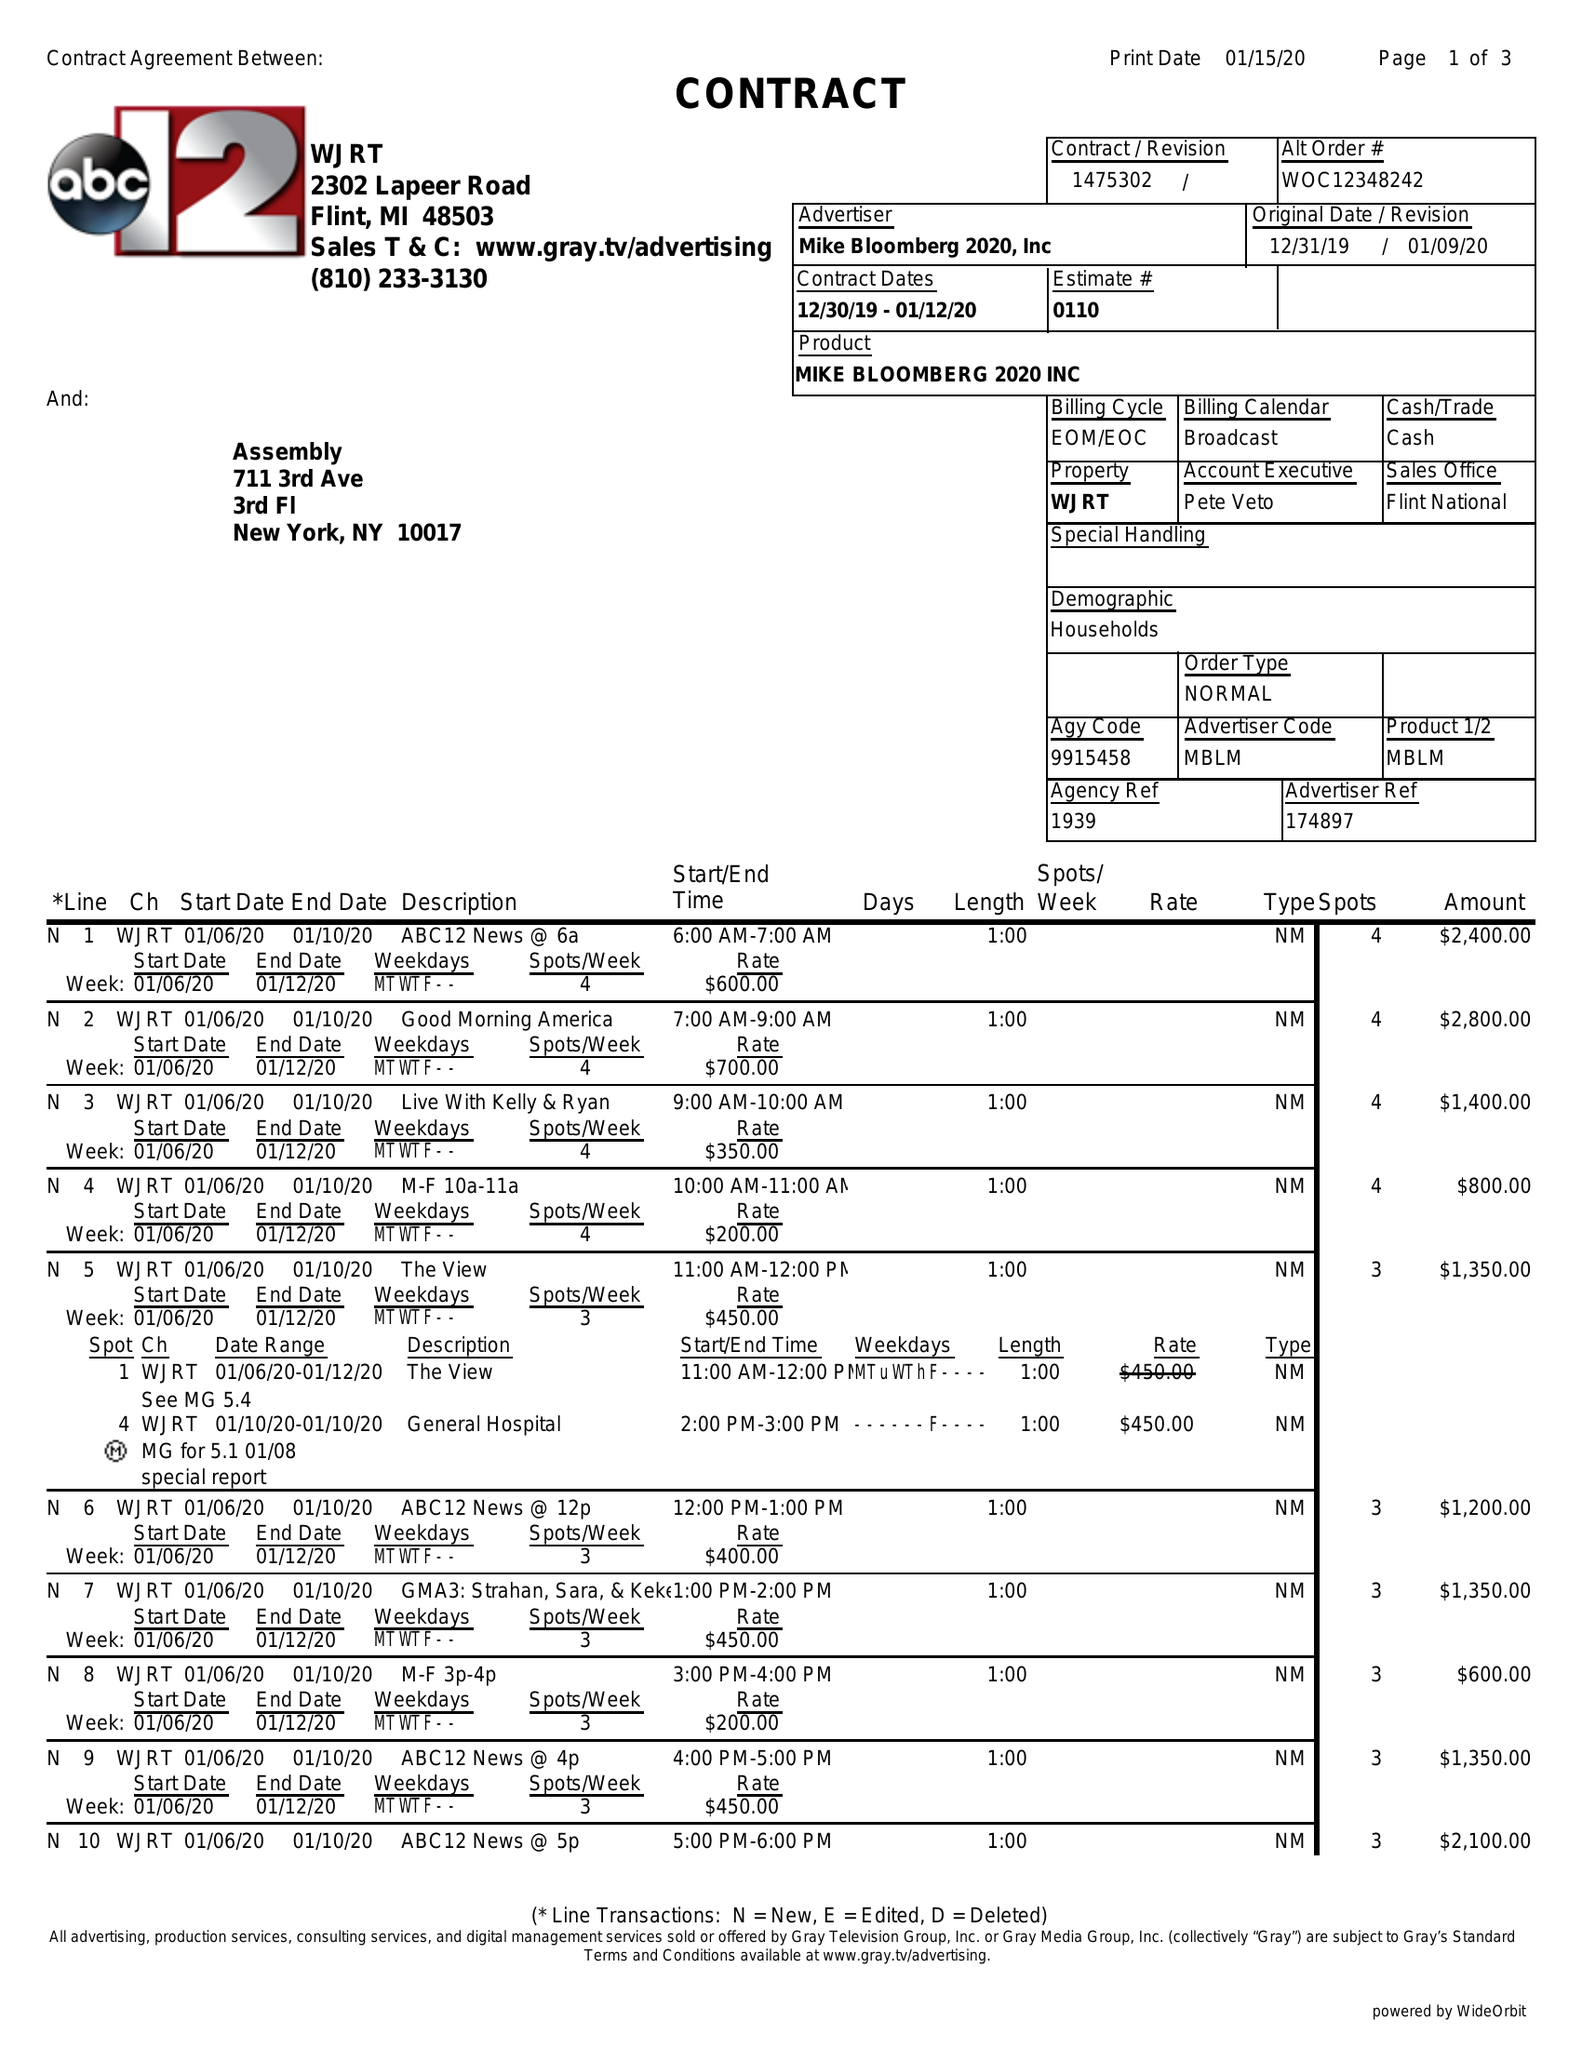What is the value for the flight_to?
Answer the question using a single word or phrase. 01/12/20 